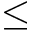Convert formula to latex. <formula><loc_0><loc_0><loc_500><loc_500>\leq</formula> 